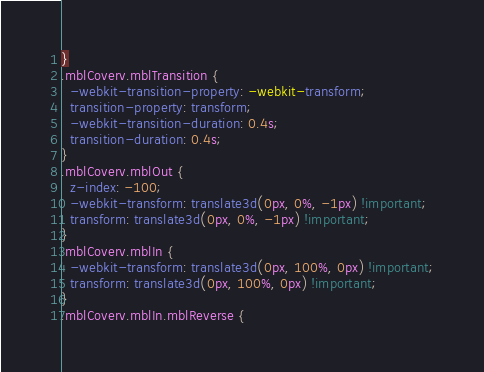<code> <loc_0><loc_0><loc_500><loc_500><_CSS_>}
.mblCoverv.mblTransition {
  -webkit-transition-property: -webkit-transform;
  transition-property: transform;
  -webkit-transition-duration: 0.4s;
  transition-duration: 0.4s;
}
.mblCoverv.mblOut {
  z-index: -100;
  -webkit-transform: translate3d(0px, 0%, -1px) !important;
  transform: translate3d(0px, 0%, -1px) !important;
}
.mblCoverv.mblIn {
  -webkit-transform: translate3d(0px, 100%, 0px) !important;
  transform: translate3d(0px, 100%, 0px) !important;
}
.mblCoverv.mblIn.mblReverse {</code> 